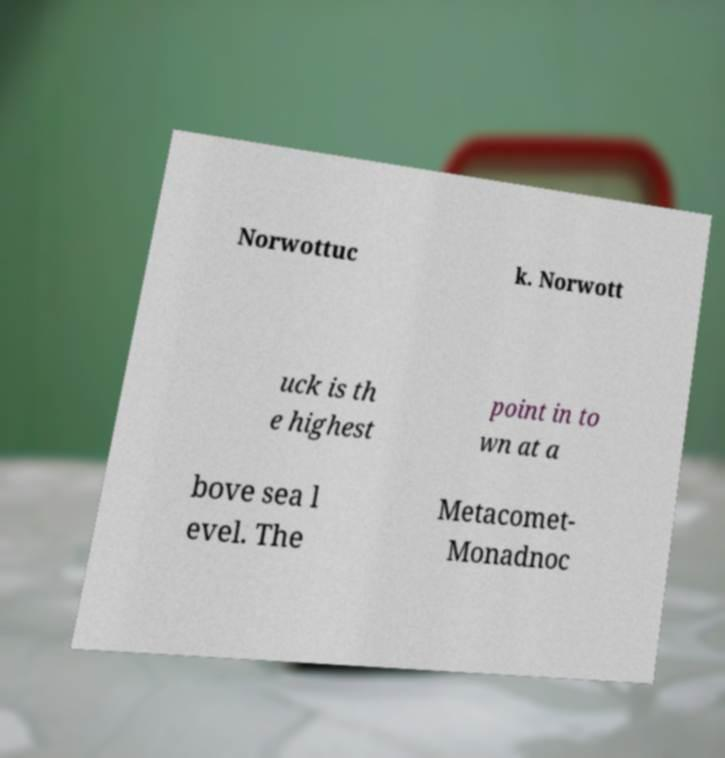For documentation purposes, I need the text within this image transcribed. Could you provide that? Norwottuc k. Norwott uck is th e highest point in to wn at a bove sea l evel. The Metacomet- Monadnoc 